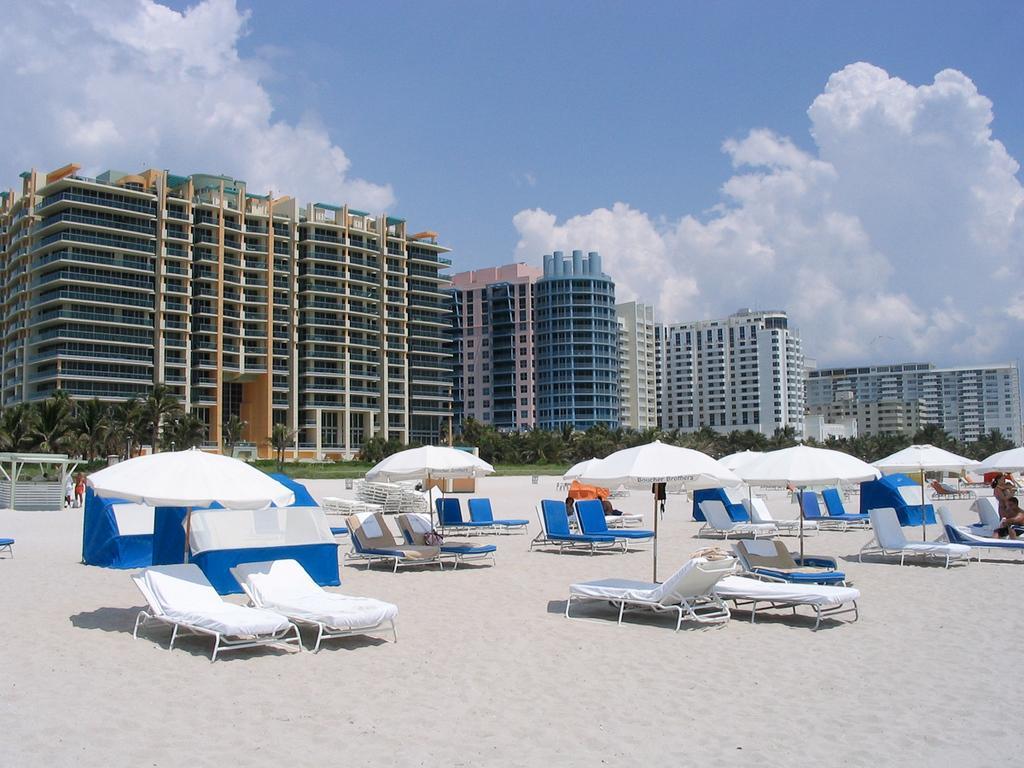Can you describe this image briefly? At the bottom of the image we can see shacks, umbrellas, chairs and sand. In the background we can see trees, buildings, sky and clouds. 